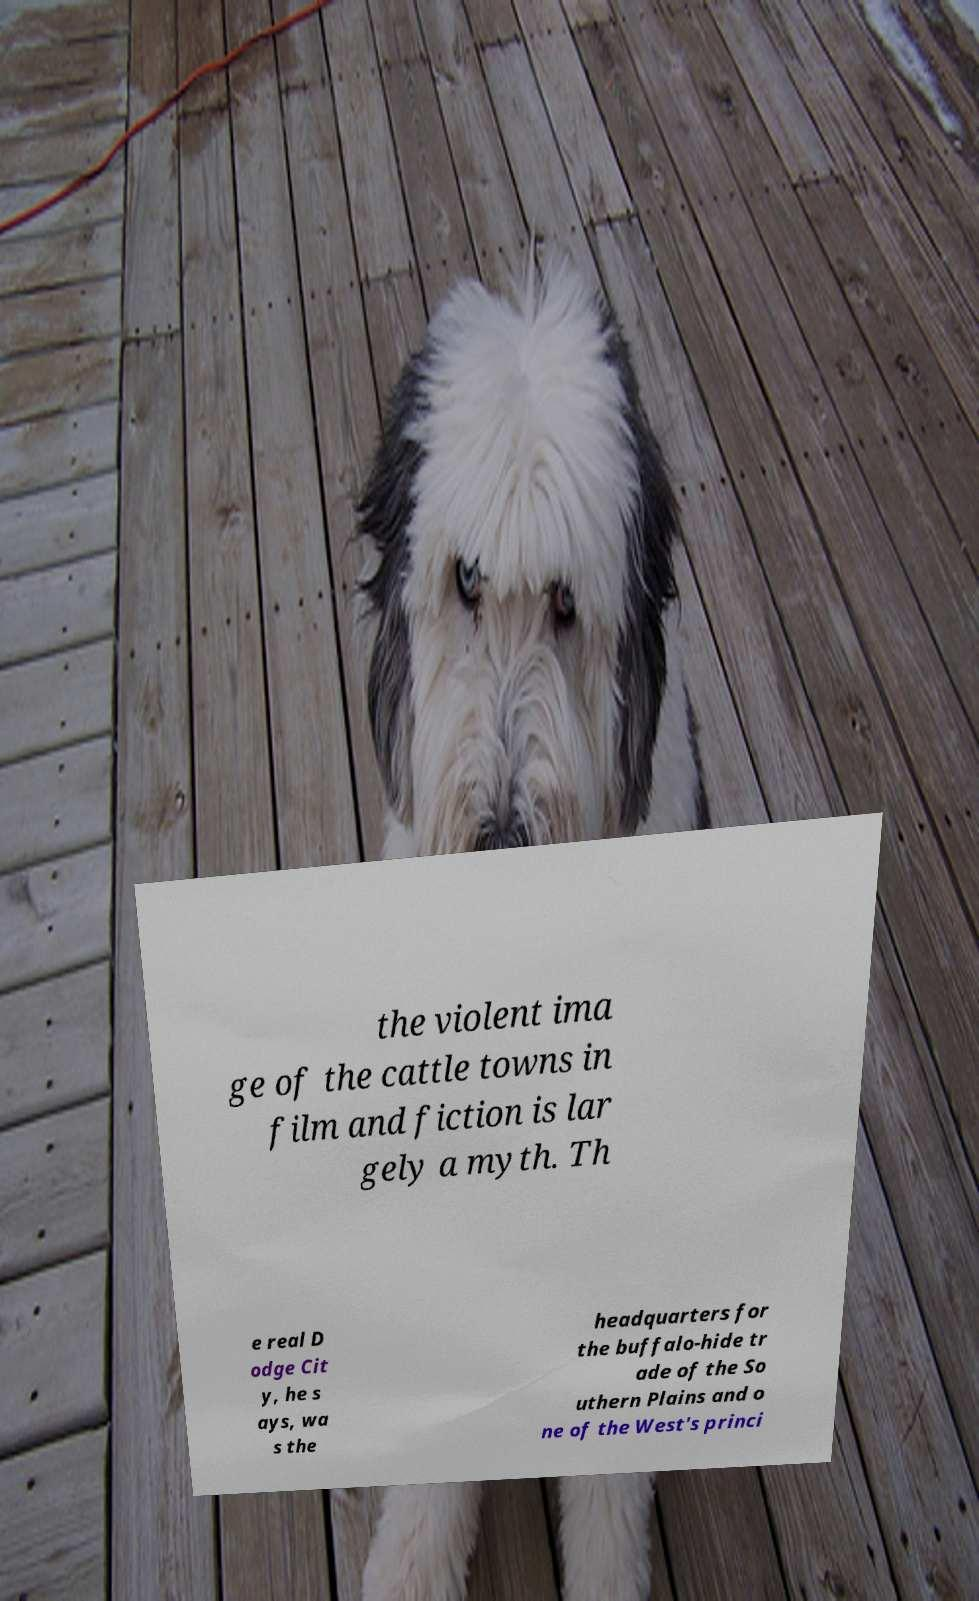What messages or text are displayed in this image? I need them in a readable, typed format. the violent ima ge of the cattle towns in film and fiction is lar gely a myth. Th e real D odge Cit y, he s ays, wa s the headquarters for the buffalo-hide tr ade of the So uthern Plains and o ne of the West's princi 